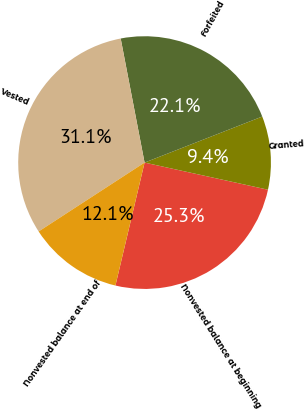<chart> <loc_0><loc_0><loc_500><loc_500><pie_chart><fcel>Nonvested balance at beginning<fcel>Granted<fcel>Forfeited<fcel>Vested<fcel>Nonvested balance at end of<nl><fcel>25.26%<fcel>9.38%<fcel>22.09%<fcel>31.15%<fcel>12.12%<nl></chart> 